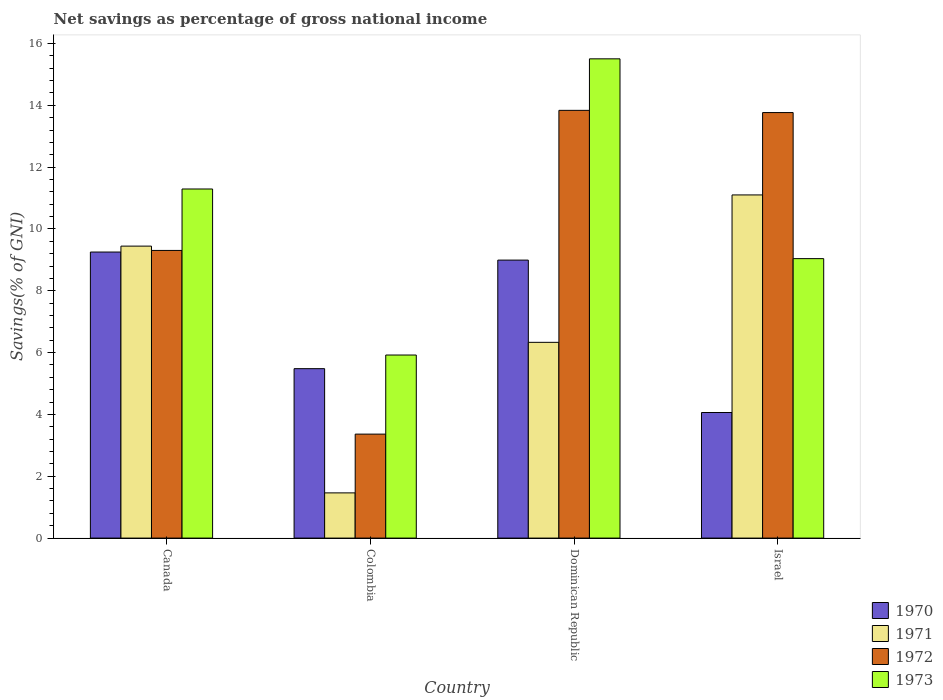How many different coloured bars are there?
Your answer should be very brief. 4. How many groups of bars are there?
Your answer should be very brief. 4. Are the number of bars per tick equal to the number of legend labels?
Offer a terse response. Yes. Are the number of bars on each tick of the X-axis equal?
Provide a succinct answer. Yes. How many bars are there on the 1st tick from the left?
Ensure brevity in your answer.  4. What is the total savings in 1972 in Colombia?
Provide a succinct answer. 3.36. Across all countries, what is the maximum total savings in 1971?
Give a very brief answer. 11.1. Across all countries, what is the minimum total savings in 1971?
Give a very brief answer. 1.46. In which country was the total savings in 1970 minimum?
Offer a very short reply. Israel. What is the total total savings in 1970 in the graph?
Your answer should be very brief. 27.79. What is the difference between the total savings in 1971 in Canada and that in Dominican Republic?
Offer a very short reply. 3.11. What is the difference between the total savings in 1970 in Israel and the total savings in 1972 in Canada?
Provide a short and direct response. -5.24. What is the average total savings in 1971 per country?
Offer a terse response. 7.09. What is the difference between the total savings of/in 1970 and total savings of/in 1973 in Dominican Republic?
Your answer should be very brief. -6.51. In how many countries, is the total savings in 1973 greater than 15.2 %?
Your response must be concise. 1. What is the ratio of the total savings in 1973 in Canada to that in Israel?
Provide a short and direct response. 1.25. Is the difference between the total savings in 1970 in Canada and Colombia greater than the difference between the total savings in 1973 in Canada and Colombia?
Give a very brief answer. No. What is the difference between the highest and the second highest total savings in 1971?
Keep it short and to the point. -1.66. What is the difference between the highest and the lowest total savings in 1971?
Offer a terse response. 9.64. In how many countries, is the total savings in 1971 greater than the average total savings in 1971 taken over all countries?
Provide a short and direct response. 2. What does the 2nd bar from the right in Dominican Republic represents?
Ensure brevity in your answer.  1972. What is the difference between two consecutive major ticks on the Y-axis?
Provide a succinct answer. 2. Does the graph contain grids?
Your answer should be compact. No. Where does the legend appear in the graph?
Offer a terse response. Bottom right. How are the legend labels stacked?
Your response must be concise. Vertical. What is the title of the graph?
Provide a short and direct response. Net savings as percentage of gross national income. Does "2007" appear as one of the legend labels in the graph?
Your response must be concise. No. What is the label or title of the Y-axis?
Give a very brief answer. Savings(% of GNI). What is the Savings(% of GNI) in 1970 in Canada?
Give a very brief answer. 9.25. What is the Savings(% of GNI) of 1971 in Canada?
Make the answer very short. 9.45. What is the Savings(% of GNI) of 1972 in Canada?
Offer a terse response. 9.31. What is the Savings(% of GNI) in 1973 in Canada?
Your response must be concise. 11.29. What is the Savings(% of GNI) of 1970 in Colombia?
Give a very brief answer. 5.48. What is the Savings(% of GNI) in 1971 in Colombia?
Your answer should be compact. 1.46. What is the Savings(% of GNI) in 1972 in Colombia?
Give a very brief answer. 3.36. What is the Savings(% of GNI) of 1973 in Colombia?
Offer a terse response. 5.92. What is the Savings(% of GNI) in 1970 in Dominican Republic?
Provide a succinct answer. 8.99. What is the Savings(% of GNI) in 1971 in Dominican Republic?
Provide a succinct answer. 6.33. What is the Savings(% of GNI) of 1972 in Dominican Republic?
Provide a succinct answer. 13.84. What is the Savings(% of GNI) in 1973 in Dominican Republic?
Ensure brevity in your answer.  15.5. What is the Savings(% of GNI) of 1970 in Israel?
Make the answer very short. 4.06. What is the Savings(% of GNI) of 1971 in Israel?
Your response must be concise. 11.1. What is the Savings(% of GNI) of 1972 in Israel?
Make the answer very short. 13.77. What is the Savings(% of GNI) in 1973 in Israel?
Your response must be concise. 9.04. Across all countries, what is the maximum Savings(% of GNI) of 1970?
Give a very brief answer. 9.25. Across all countries, what is the maximum Savings(% of GNI) of 1971?
Ensure brevity in your answer.  11.1. Across all countries, what is the maximum Savings(% of GNI) in 1972?
Your answer should be very brief. 13.84. Across all countries, what is the maximum Savings(% of GNI) of 1973?
Offer a terse response. 15.5. Across all countries, what is the minimum Savings(% of GNI) of 1970?
Your answer should be compact. 4.06. Across all countries, what is the minimum Savings(% of GNI) in 1971?
Provide a succinct answer. 1.46. Across all countries, what is the minimum Savings(% of GNI) of 1972?
Provide a short and direct response. 3.36. Across all countries, what is the minimum Savings(% of GNI) of 1973?
Make the answer very short. 5.92. What is the total Savings(% of GNI) in 1970 in the graph?
Give a very brief answer. 27.79. What is the total Savings(% of GNI) in 1971 in the graph?
Offer a terse response. 28.34. What is the total Savings(% of GNI) of 1972 in the graph?
Provide a succinct answer. 40.27. What is the total Savings(% of GNI) of 1973 in the graph?
Offer a terse response. 41.76. What is the difference between the Savings(% of GNI) of 1970 in Canada and that in Colombia?
Offer a very short reply. 3.77. What is the difference between the Savings(% of GNI) in 1971 in Canada and that in Colombia?
Keep it short and to the point. 7.98. What is the difference between the Savings(% of GNI) of 1972 in Canada and that in Colombia?
Give a very brief answer. 5.94. What is the difference between the Savings(% of GNI) of 1973 in Canada and that in Colombia?
Your response must be concise. 5.37. What is the difference between the Savings(% of GNI) in 1970 in Canada and that in Dominican Republic?
Offer a terse response. 0.26. What is the difference between the Savings(% of GNI) of 1971 in Canada and that in Dominican Republic?
Keep it short and to the point. 3.11. What is the difference between the Savings(% of GNI) of 1972 in Canada and that in Dominican Republic?
Keep it short and to the point. -4.53. What is the difference between the Savings(% of GNI) of 1973 in Canada and that in Dominican Republic?
Keep it short and to the point. -4.21. What is the difference between the Savings(% of GNI) in 1970 in Canada and that in Israel?
Make the answer very short. 5.19. What is the difference between the Savings(% of GNI) in 1971 in Canada and that in Israel?
Give a very brief answer. -1.66. What is the difference between the Savings(% of GNI) of 1972 in Canada and that in Israel?
Make the answer very short. -4.46. What is the difference between the Savings(% of GNI) in 1973 in Canada and that in Israel?
Offer a terse response. 2.25. What is the difference between the Savings(% of GNI) of 1970 in Colombia and that in Dominican Republic?
Your answer should be very brief. -3.51. What is the difference between the Savings(% of GNI) of 1971 in Colombia and that in Dominican Republic?
Offer a terse response. -4.87. What is the difference between the Savings(% of GNI) in 1972 in Colombia and that in Dominican Republic?
Offer a very short reply. -10.47. What is the difference between the Savings(% of GNI) in 1973 in Colombia and that in Dominican Republic?
Provide a short and direct response. -9.58. What is the difference between the Savings(% of GNI) of 1970 in Colombia and that in Israel?
Ensure brevity in your answer.  1.42. What is the difference between the Savings(% of GNI) of 1971 in Colombia and that in Israel?
Your answer should be compact. -9.64. What is the difference between the Savings(% of GNI) in 1972 in Colombia and that in Israel?
Your response must be concise. -10.4. What is the difference between the Savings(% of GNI) in 1973 in Colombia and that in Israel?
Offer a very short reply. -3.12. What is the difference between the Savings(% of GNI) of 1970 in Dominican Republic and that in Israel?
Offer a terse response. 4.93. What is the difference between the Savings(% of GNI) of 1971 in Dominican Republic and that in Israel?
Ensure brevity in your answer.  -4.77. What is the difference between the Savings(% of GNI) in 1972 in Dominican Republic and that in Israel?
Ensure brevity in your answer.  0.07. What is the difference between the Savings(% of GNI) in 1973 in Dominican Republic and that in Israel?
Provide a short and direct response. 6.46. What is the difference between the Savings(% of GNI) of 1970 in Canada and the Savings(% of GNI) of 1971 in Colombia?
Ensure brevity in your answer.  7.79. What is the difference between the Savings(% of GNI) of 1970 in Canada and the Savings(% of GNI) of 1972 in Colombia?
Provide a succinct answer. 5.89. What is the difference between the Savings(% of GNI) of 1970 in Canada and the Savings(% of GNI) of 1973 in Colombia?
Give a very brief answer. 3.33. What is the difference between the Savings(% of GNI) of 1971 in Canada and the Savings(% of GNI) of 1972 in Colombia?
Offer a terse response. 6.08. What is the difference between the Savings(% of GNI) in 1971 in Canada and the Savings(% of GNI) in 1973 in Colombia?
Provide a short and direct response. 3.52. What is the difference between the Savings(% of GNI) of 1972 in Canada and the Savings(% of GNI) of 1973 in Colombia?
Your response must be concise. 3.38. What is the difference between the Savings(% of GNI) of 1970 in Canada and the Savings(% of GNI) of 1971 in Dominican Republic?
Make the answer very short. 2.92. What is the difference between the Savings(% of GNI) in 1970 in Canada and the Savings(% of GNI) in 1972 in Dominican Republic?
Ensure brevity in your answer.  -4.58. What is the difference between the Savings(% of GNI) of 1970 in Canada and the Savings(% of GNI) of 1973 in Dominican Republic?
Offer a terse response. -6.25. What is the difference between the Savings(% of GNI) of 1971 in Canada and the Savings(% of GNI) of 1972 in Dominican Republic?
Make the answer very short. -4.39. What is the difference between the Savings(% of GNI) in 1971 in Canada and the Savings(% of GNI) in 1973 in Dominican Republic?
Your answer should be very brief. -6.06. What is the difference between the Savings(% of GNI) of 1972 in Canada and the Savings(% of GNI) of 1973 in Dominican Republic?
Provide a short and direct response. -6.2. What is the difference between the Savings(% of GNI) of 1970 in Canada and the Savings(% of GNI) of 1971 in Israel?
Your answer should be very brief. -1.85. What is the difference between the Savings(% of GNI) in 1970 in Canada and the Savings(% of GNI) in 1972 in Israel?
Your response must be concise. -4.51. What is the difference between the Savings(% of GNI) of 1970 in Canada and the Savings(% of GNI) of 1973 in Israel?
Your answer should be very brief. 0.21. What is the difference between the Savings(% of GNI) in 1971 in Canada and the Savings(% of GNI) in 1972 in Israel?
Your answer should be very brief. -4.32. What is the difference between the Savings(% of GNI) in 1971 in Canada and the Savings(% of GNI) in 1973 in Israel?
Your answer should be very brief. 0.4. What is the difference between the Savings(% of GNI) in 1972 in Canada and the Savings(% of GNI) in 1973 in Israel?
Your answer should be very brief. 0.27. What is the difference between the Savings(% of GNI) in 1970 in Colombia and the Savings(% of GNI) in 1971 in Dominican Republic?
Offer a terse response. -0.85. What is the difference between the Savings(% of GNI) in 1970 in Colombia and the Savings(% of GNI) in 1972 in Dominican Republic?
Provide a succinct answer. -8.36. What is the difference between the Savings(% of GNI) in 1970 in Colombia and the Savings(% of GNI) in 1973 in Dominican Republic?
Make the answer very short. -10.02. What is the difference between the Savings(% of GNI) of 1971 in Colombia and the Savings(% of GNI) of 1972 in Dominican Republic?
Your answer should be very brief. -12.38. What is the difference between the Savings(% of GNI) in 1971 in Colombia and the Savings(% of GNI) in 1973 in Dominican Republic?
Provide a short and direct response. -14.04. What is the difference between the Savings(% of GNI) of 1972 in Colombia and the Savings(% of GNI) of 1973 in Dominican Republic?
Your answer should be very brief. -12.14. What is the difference between the Savings(% of GNI) of 1970 in Colombia and the Savings(% of GNI) of 1971 in Israel?
Your answer should be very brief. -5.62. What is the difference between the Savings(% of GNI) of 1970 in Colombia and the Savings(% of GNI) of 1972 in Israel?
Give a very brief answer. -8.28. What is the difference between the Savings(% of GNI) of 1970 in Colombia and the Savings(% of GNI) of 1973 in Israel?
Your answer should be compact. -3.56. What is the difference between the Savings(% of GNI) of 1971 in Colombia and the Savings(% of GNI) of 1972 in Israel?
Your response must be concise. -12.3. What is the difference between the Savings(% of GNI) of 1971 in Colombia and the Savings(% of GNI) of 1973 in Israel?
Your answer should be compact. -7.58. What is the difference between the Savings(% of GNI) of 1972 in Colombia and the Savings(% of GNI) of 1973 in Israel?
Provide a succinct answer. -5.68. What is the difference between the Savings(% of GNI) in 1970 in Dominican Republic and the Savings(% of GNI) in 1971 in Israel?
Offer a very short reply. -2.11. What is the difference between the Savings(% of GNI) of 1970 in Dominican Republic and the Savings(% of GNI) of 1972 in Israel?
Give a very brief answer. -4.77. What is the difference between the Savings(% of GNI) in 1970 in Dominican Republic and the Savings(% of GNI) in 1973 in Israel?
Your answer should be compact. -0.05. What is the difference between the Savings(% of GNI) of 1971 in Dominican Republic and the Savings(% of GNI) of 1972 in Israel?
Your response must be concise. -7.43. What is the difference between the Savings(% of GNI) in 1971 in Dominican Republic and the Savings(% of GNI) in 1973 in Israel?
Your answer should be very brief. -2.71. What is the difference between the Savings(% of GNI) in 1972 in Dominican Republic and the Savings(% of GNI) in 1973 in Israel?
Your response must be concise. 4.8. What is the average Savings(% of GNI) in 1970 per country?
Your answer should be compact. 6.95. What is the average Savings(% of GNI) of 1971 per country?
Ensure brevity in your answer.  7.09. What is the average Savings(% of GNI) in 1972 per country?
Ensure brevity in your answer.  10.07. What is the average Savings(% of GNI) in 1973 per country?
Your answer should be compact. 10.44. What is the difference between the Savings(% of GNI) of 1970 and Savings(% of GNI) of 1971 in Canada?
Offer a terse response. -0.19. What is the difference between the Savings(% of GNI) in 1970 and Savings(% of GNI) in 1972 in Canada?
Make the answer very short. -0.05. What is the difference between the Savings(% of GNI) in 1970 and Savings(% of GNI) in 1973 in Canada?
Make the answer very short. -2.04. What is the difference between the Savings(% of GNI) in 1971 and Savings(% of GNI) in 1972 in Canada?
Offer a very short reply. 0.14. What is the difference between the Savings(% of GNI) of 1971 and Savings(% of GNI) of 1973 in Canada?
Ensure brevity in your answer.  -1.85. What is the difference between the Savings(% of GNI) of 1972 and Savings(% of GNI) of 1973 in Canada?
Give a very brief answer. -1.99. What is the difference between the Savings(% of GNI) in 1970 and Savings(% of GNI) in 1971 in Colombia?
Ensure brevity in your answer.  4.02. What is the difference between the Savings(% of GNI) in 1970 and Savings(% of GNI) in 1972 in Colombia?
Offer a terse response. 2.12. What is the difference between the Savings(% of GNI) of 1970 and Savings(% of GNI) of 1973 in Colombia?
Your answer should be compact. -0.44. What is the difference between the Savings(% of GNI) in 1971 and Savings(% of GNI) in 1972 in Colombia?
Offer a very short reply. -1.9. What is the difference between the Savings(% of GNI) of 1971 and Savings(% of GNI) of 1973 in Colombia?
Provide a short and direct response. -4.46. What is the difference between the Savings(% of GNI) of 1972 and Savings(% of GNI) of 1973 in Colombia?
Offer a terse response. -2.56. What is the difference between the Savings(% of GNI) of 1970 and Savings(% of GNI) of 1971 in Dominican Republic?
Keep it short and to the point. 2.66. What is the difference between the Savings(% of GNI) in 1970 and Savings(% of GNI) in 1972 in Dominican Republic?
Offer a very short reply. -4.84. What is the difference between the Savings(% of GNI) of 1970 and Savings(% of GNI) of 1973 in Dominican Republic?
Provide a succinct answer. -6.51. What is the difference between the Savings(% of GNI) in 1971 and Savings(% of GNI) in 1972 in Dominican Republic?
Ensure brevity in your answer.  -7.5. What is the difference between the Savings(% of GNI) in 1971 and Savings(% of GNI) in 1973 in Dominican Republic?
Offer a very short reply. -9.17. What is the difference between the Savings(% of GNI) of 1972 and Savings(% of GNI) of 1973 in Dominican Republic?
Your answer should be very brief. -1.67. What is the difference between the Savings(% of GNI) of 1970 and Savings(% of GNI) of 1971 in Israel?
Ensure brevity in your answer.  -7.04. What is the difference between the Savings(% of GNI) of 1970 and Savings(% of GNI) of 1972 in Israel?
Provide a short and direct response. -9.7. What is the difference between the Savings(% of GNI) in 1970 and Savings(% of GNI) in 1973 in Israel?
Ensure brevity in your answer.  -4.98. What is the difference between the Savings(% of GNI) in 1971 and Savings(% of GNI) in 1972 in Israel?
Your answer should be compact. -2.66. What is the difference between the Savings(% of GNI) in 1971 and Savings(% of GNI) in 1973 in Israel?
Offer a very short reply. 2.06. What is the difference between the Savings(% of GNI) in 1972 and Savings(% of GNI) in 1973 in Israel?
Ensure brevity in your answer.  4.73. What is the ratio of the Savings(% of GNI) of 1970 in Canada to that in Colombia?
Your answer should be compact. 1.69. What is the ratio of the Savings(% of GNI) in 1971 in Canada to that in Colombia?
Your answer should be compact. 6.46. What is the ratio of the Savings(% of GNI) of 1972 in Canada to that in Colombia?
Keep it short and to the point. 2.77. What is the ratio of the Savings(% of GNI) of 1973 in Canada to that in Colombia?
Provide a succinct answer. 1.91. What is the ratio of the Savings(% of GNI) of 1971 in Canada to that in Dominican Republic?
Give a very brief answer. 1.49. What is the ratio of the Savings(% of GNI) of 1972 in Canada to that in Dominican Republic?
Ensure brevity in your answer.  0.67. What is the ratio of the Savings(% of GNI) in 1973 in Canada to that in Dominican Republic?
Offer a terse response. 0.73. What is the ratio of the Savings(% of GNI) of 1970 in Canada to that in Israel?
Provide a short and direct response. 2.28. What is the ratio of the Savings(% of GNI) of 1971 in Canada to that in Israel?
Make the answer very short. 0.85. What is the ratio of the Savings(% of GNI) in 1972 in Canada to that in Israel?
Give a very brief answer. 0.68. What is the ratio of the Savings(% of GNI) in 1973 in Canada to that in Israel?
Give a very brief answer. 1.25. What is the ratio of the Savings(% of GNI) in 1970 in Colombia to that in Dominican Republic?
Provide a succinct answer. 0.61. What is the ratio of the Savings(% of GNI) in 1971 in Colombia to that in Dominican Republic?
Make the answer very short. 0.23. What is the ratio of the Savings(% of GNI) in 1972 in Colombia to that in Dominican Republic?
Make the answer very short. 0.24. What is the ratio of the Savings(% of GNI) of 1973 in Colombia to that in Dominican Republic?
Your answer should be very brief. 0.38. What is the ratio of the Savings(% of GNI) in 1970 in Colombia to that in Israel?
Offer a very short reply. 1.35. What is the ratio of the Savings(% of GNI) in 1971 in Colombia to that in Israel?
Offer a very short reply. 0.13. What is the ratio of the Savings(% of GNI) of 1972 in Colombia to that in Israel?
Your response must be concise. 0.24. What is the ratio of the Savings(% of GNI) in 1973 in Colombia to that in Israel?
Give a very brief answer. 0.66. What is the ratio of the Savings(% of GNI) in 1970 in Dominican Republic to that in Israel?
Offer a very short reply. 2.21. What is the ratio of the Savings(% of GNI) of 1971 in Dominican Republic to that in Israel?
Offer a terse response. 0.57. What is the ratio of the Savings(% of GNI) of 1972 in Dominican Republic to that in Israel?
Ensure brevity in your answer.  1.01. What is the ratio of the Savings(% of GNI) of 1973 in Dominican Republic to that in Israel?
Your answer should be compact. 1.71. What is the difference between the highest and the second highest Savings(% of GNI) of 1970?
Provide a short and direct response. 0.26. What is the difference between the highest and the second highest Savings(% of GNI) of 1971?
Provide a succinct answer. 1.66. What is the difference between the highest and the second highest Savings(% of GNI) in 1972?
Give a very brief answer. 0.07. What is the difference between the highest and the second highest Savings(% of GNI) of 1973?
Your answer should be compact. 4.21. What is the difference between the highest and the lowest Savings(% of GNI) of 1970?
Your answer should be very brief. 5.19. What is the difference between the highest and the lowest Savings(% of GNI) in 1971?
Provide a short and direct response. 9.64. What is the difference between the highest and the lowest Savings(% of GNI) in 1972?
Make the answer very short. 10.47. What is the difference between the highest and the lowest Savings(% of GNI) of 1973?
Offer a terse response. 9.58. 